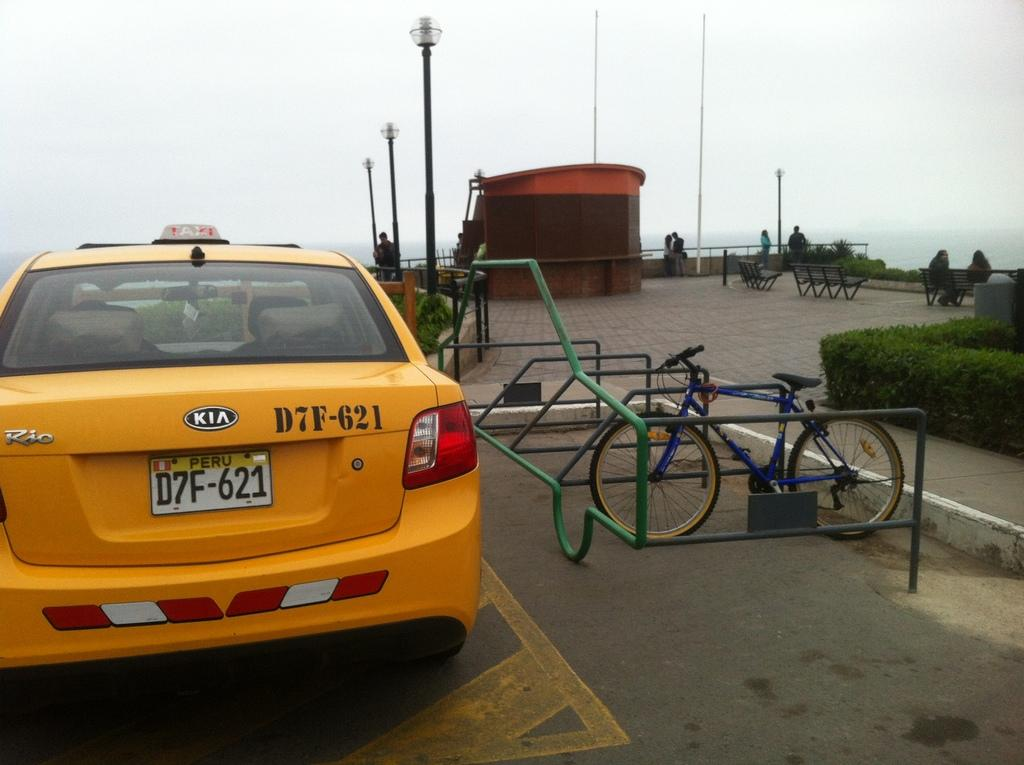<image>
Write a terse but informative summary of the picture. A yellow Kia taxi from Peru is parked by a bike rack. 